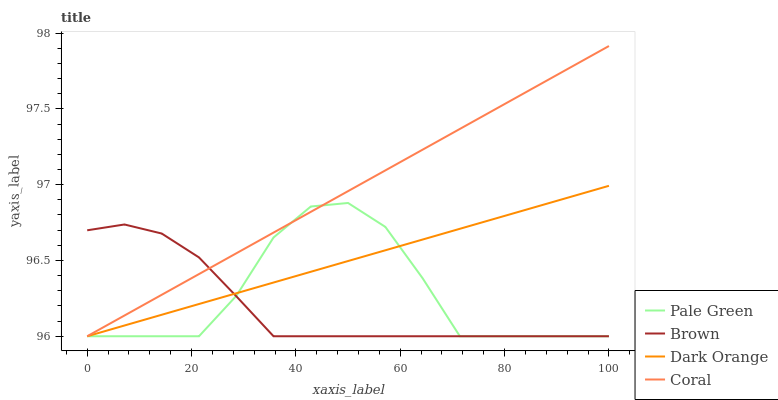Does Brown have the minimum area under the curve?
Answer yes or no. Yes. Does Coral have the maximum area under the curve?
Answer yes or no. Yes. Does Pale Green have the minimum area under the curve?
Answer yes or no. No. Does Pale Green have the maximum area under the curve?
Answer yes or no. No. Is Dark Orange the smoothest?
Answer yes or no. Yes. Is Pale Green the roughest?
Answer yes or no. Yes. Is Coral the smoothest?
Answer yes or no. No. Is Coral the roughest?
Answer yes or no. No. Does Brown have the lowest value?
Answer yes or no. Yes. Does Coral have the highest value?
Answer yes or no. Yes. Does Pale Green have the highest value?
Answer yes or no. No. Does Coral intersect Pale Green?
Answer yes or no. Yes. Is Coral less than Pale Green?
Answer yes or no. No. Is Coral greater than Pale Green?
Answer yes or no. No. 